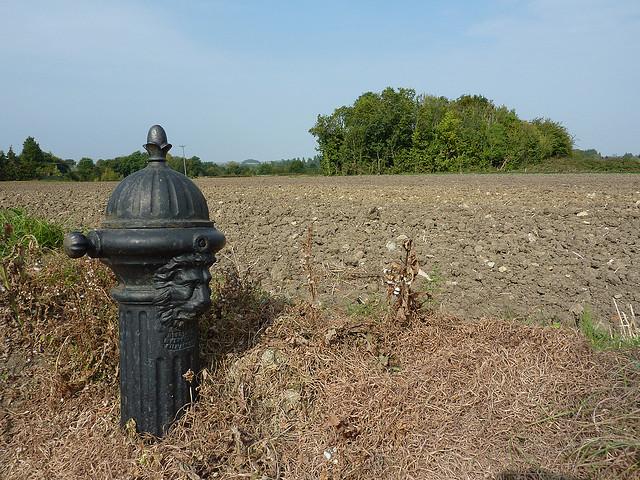What surrounds the hydrant?
Short answer required. Grass. Is the grass green?
Short answer required. No. What color is the hydrant?
Quick response, please. Black. What color is the fire hydrant?
Write a very short answer. Black. Are the crop fields lush and verdant?
Give a very brief answer. No. What animal is on this fire hydrant?
Concise answer only. Lion. What color is the grass?
Give a very brief answer. Brown. 